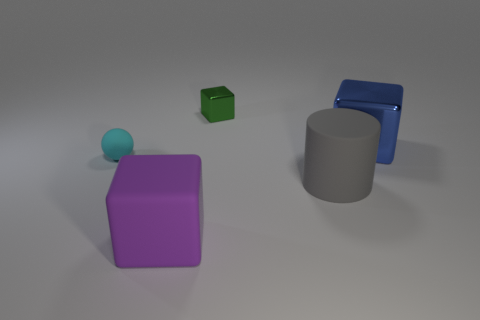Subtract all big purple matte cubes. How many cubes are left? 2 Add 2 large blue cubes. How many objects exist? 7 Subtract all yellow cubes. Subtract all gray balls. How many cubes are left? 3 Add 3 matte cubes. How many matte cubes exist? 4 Subtract 0 gray balls. How many objects are left? 5 Subtract all cubes. How many objects are left? 2 Subtract all purple rubber blocks. Subtract all large gray cylinders. How many objects are left? 3 Add 2 big gray matte cylinders. How many big gray matte cylinders are left? 3 